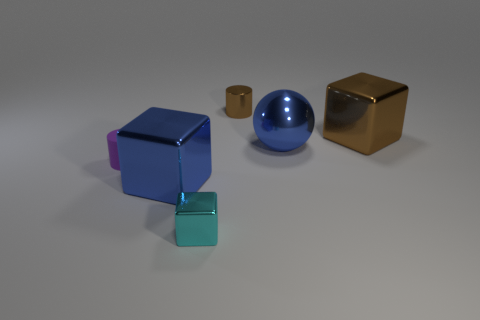Add 1 large brown cubes. How many objects exist? 7 Subtract all spheres. How many objects are left? 5 Add 4 brown cylinders. How many brown cylinders are left? 5 Add 1 small brown cylinders. How many small brown cylinders exist? 2 Subtract 0 purple cubes. How many objects are left? 6 Subtract all large yellow shiny cylinders. Subtract all small purple matte objects. How many objects are left? 5 